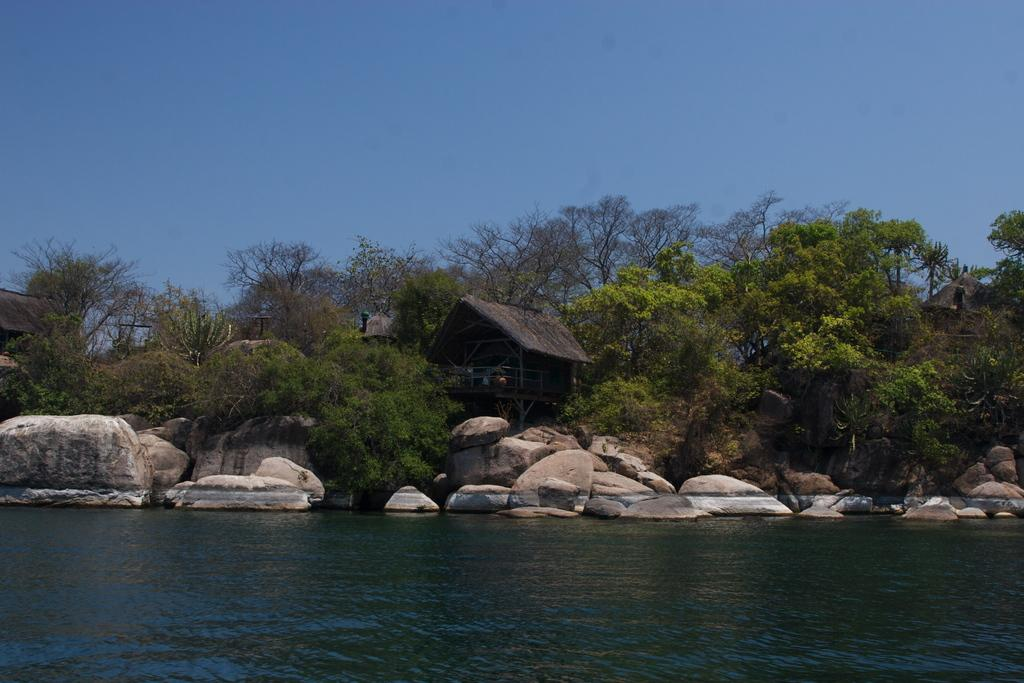What type of structures can be seen in the image? There are houses with roofs in the image. What other objects are present in the image? There are wooden poles, a large water body, rocks, and a group of trees in the image. How would you describe the sky in the image? The sky is visible in the image and appears cloudy. What type of meal is being prepared in the image? There is no indication of a meal being prepared in the image. 